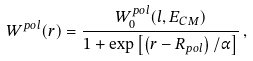Convert formula to latex. <formula><loc_0><loc_0><loc_500><loc_500>W ^ { p o l } ( r ) = \frac { W _ { 0 } ^ { p o l } ( l , E _ { C M } ) } { 1 + \exp \left [ \left ( r - R _ { p o l } \right ) / \alpha \right ] } \, ,</formula> 